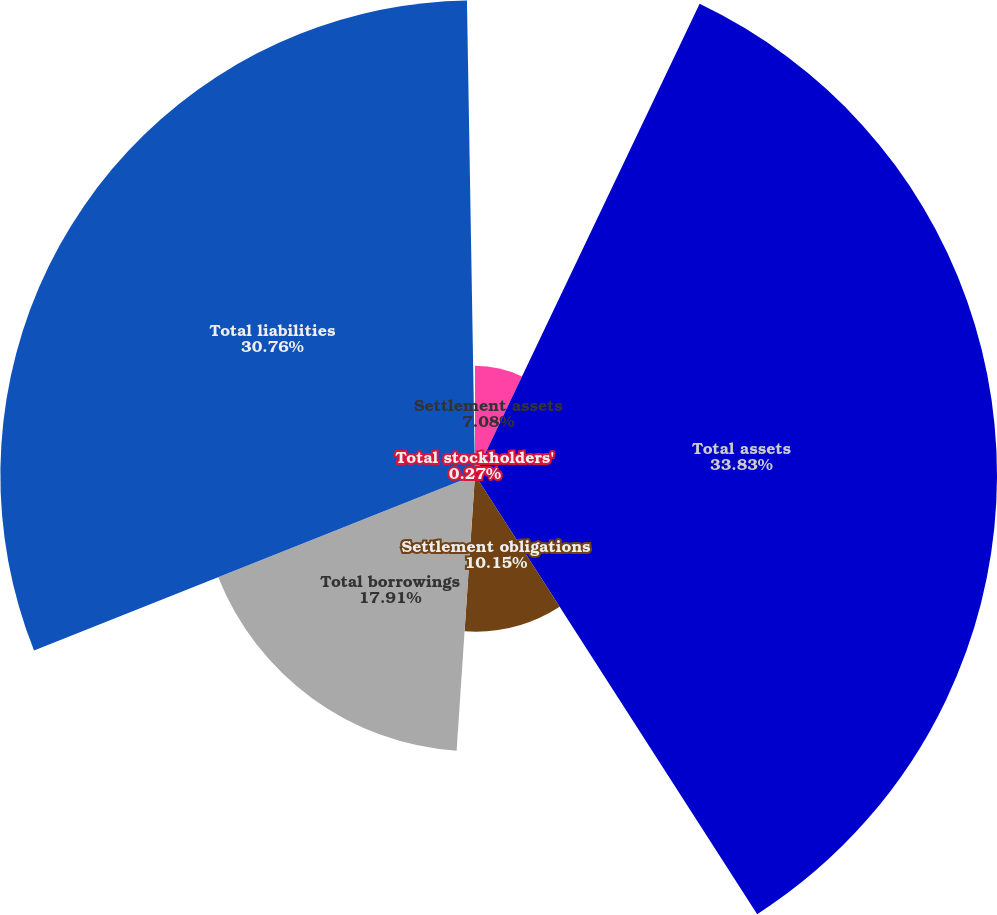Convert chart. <chart><loc_0><loc_0><loc_500><loc_500><pie_chart><fcel>Settlement assets<fcel>Total assets<fcel>Settlement obligations<fcel>Total borrowings<fcel>Total liabilities<fcel>Total stockholders'<nl><fcel>7.08%<fcel>33.83%<fcel>10.15%<fcel>17.91%<fcel>30.76%<fcel>0.27%<nl></chart> 